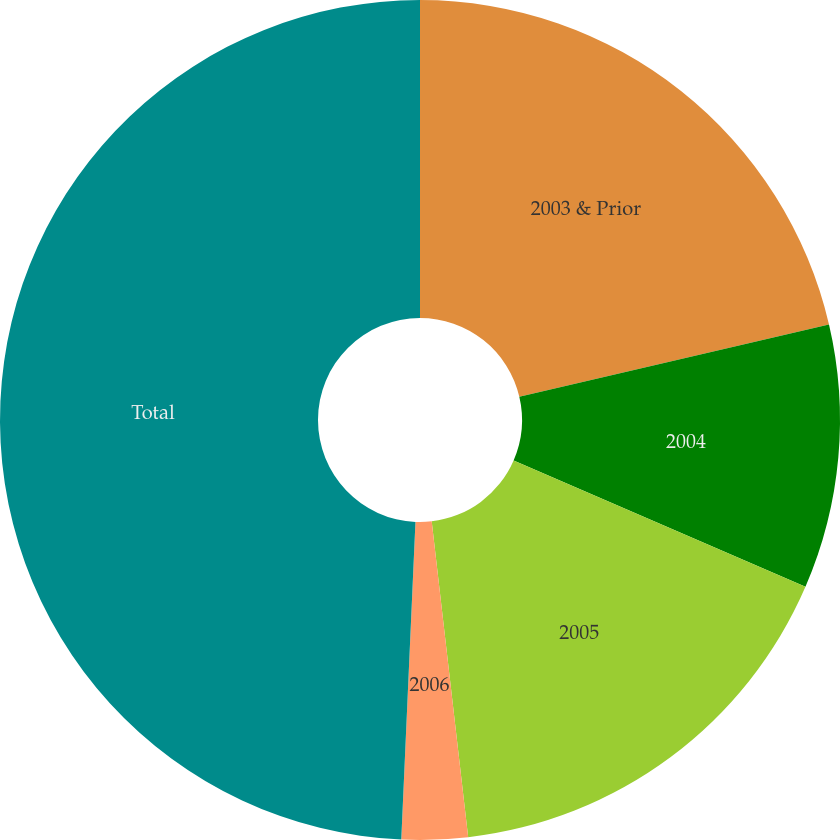Convert chart. <chart><loc_0><loc_0><loc_500><loc_500><pie_chart><fcel>2003 & Prior<fcel>2004<fcel>2005<fcel>2006<fcel>Total<nl><fcel>21.35%<fcel>10.15%<fcel>16.67%<fcel>2.54%<fcel>49.29%<nl></chart> 